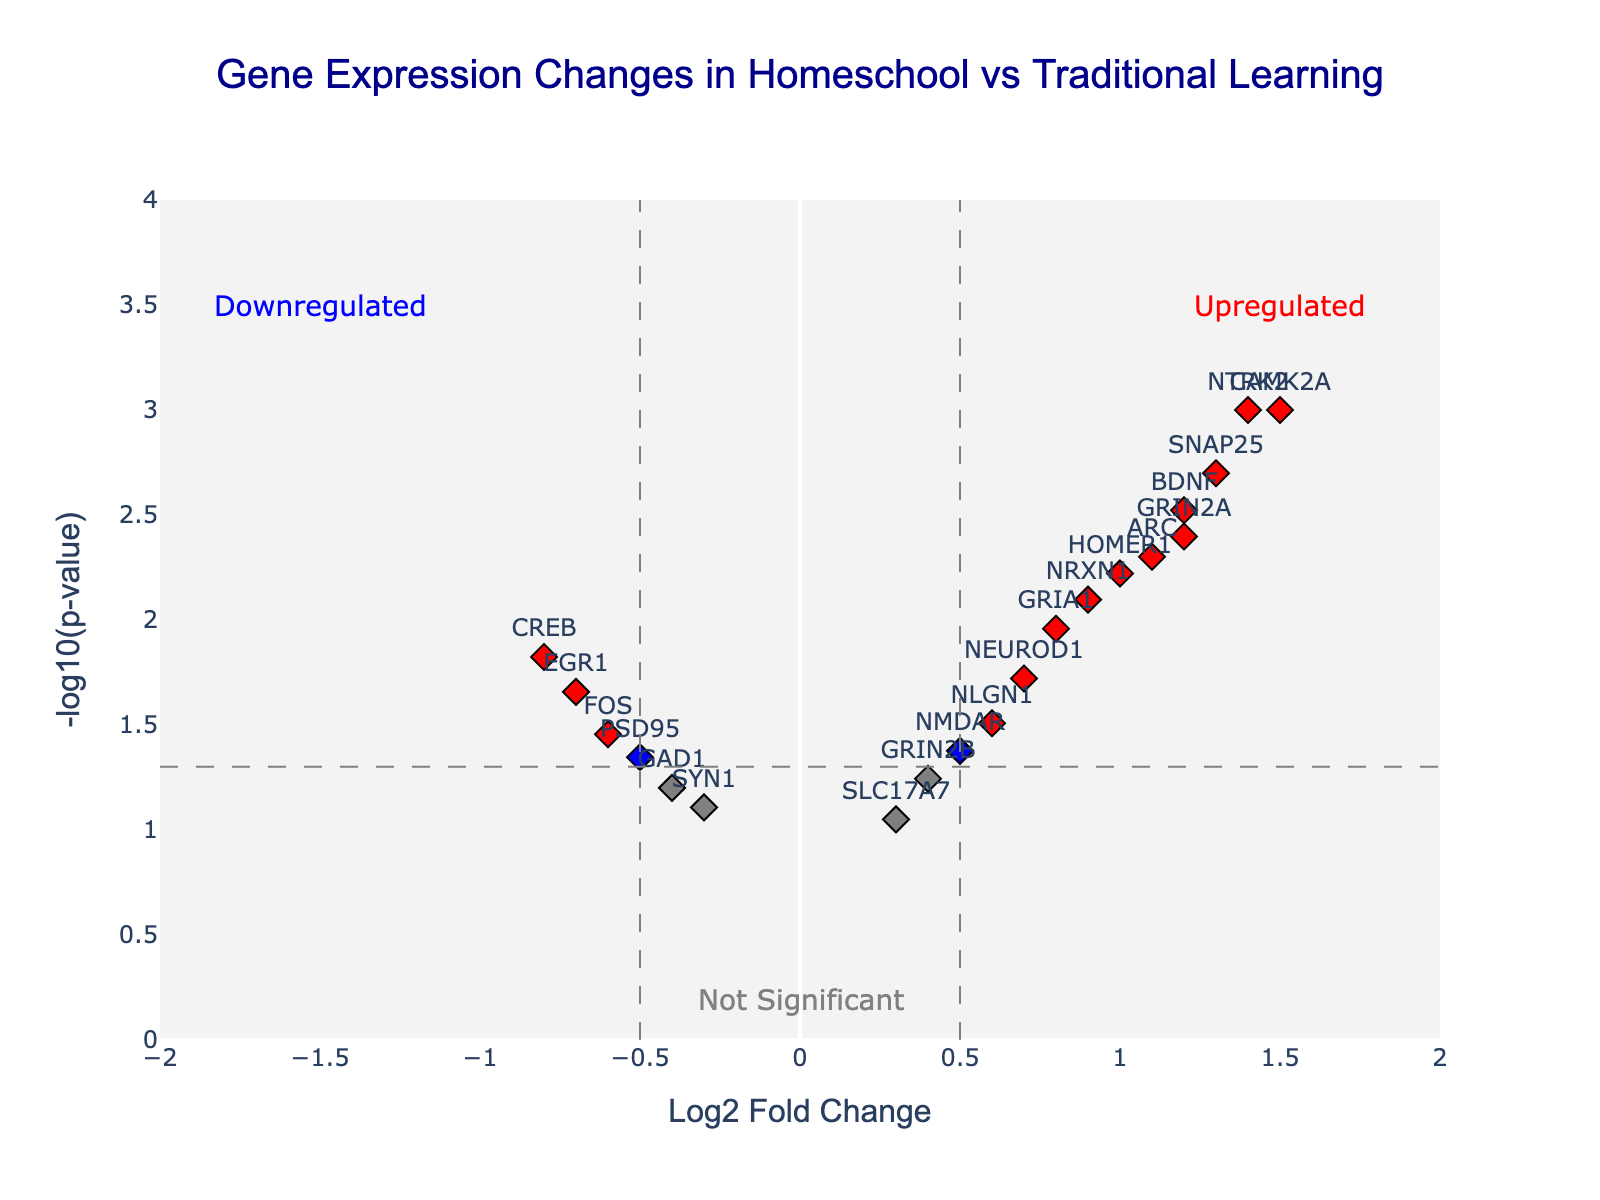How many genes are represented in the Volcano Plot? By counting each data point (identified by markers) labeled with a gene name, we can determine the total number of genes plotted.
Answer: 19 What is the title of the Volcano Plot? The title is displayed prominently at the top center of the plot.
Answer: Gene Expression Changes in Homeschool vs Traditional Learning Which gene has the highest Log2 fold change and what is its value? Locate the gene farthest to the right on the x-axis, indicating the highest Log2 fold change.
Answer: CAMK2A with a value of 1.5 How many genes have a p-value below 0.05 and a Log2 fold change greater than 0.5? Identify the red-colored markers on the plot as they meet both criteria: p-value below 0.05 and Log2 fold change greater than 0.5.
Answer: 9 What color represents genes that are not significantly different in expression, and what defines this category? Grey represents these genes; they have a p-value above 0.05 regardless of their Log2 fold change.
Answer: Grey colored; not significant Which gene represents the smallest Log2 fold change and what is its value? Identify the gene farthest to the left on the x-axis, indicating the most negative Log2 fold change.
Answer: CREB with a value of -0.8 Are there any genes classified as upregulated with significant changes, and if so, which genes fall into this category? Red-colored markers on the right side of the plot indicate upregulated genes with significant changes.
Answer: BDNF, CAMK2A, ARC, SNAP25, GRIA1, HOMER1, NTRK2, GRIN2A How many genes have a p-value above the threshold of 0.05 but a Log2 fold change below -0.5? Identify the green-colored markers on the plot which have the specified p-value and fold change criteria.
Answer: 0 Name the gene(s) with a Log2 fold change between -0.5 and 0.5 and a p-value below 0.05. Identify blue-colored markers that fall within the indicated range on both axes.
Answer: CREB, NMDAR, SYN1, PSD95, EGR1, FOS, NEUROD1 